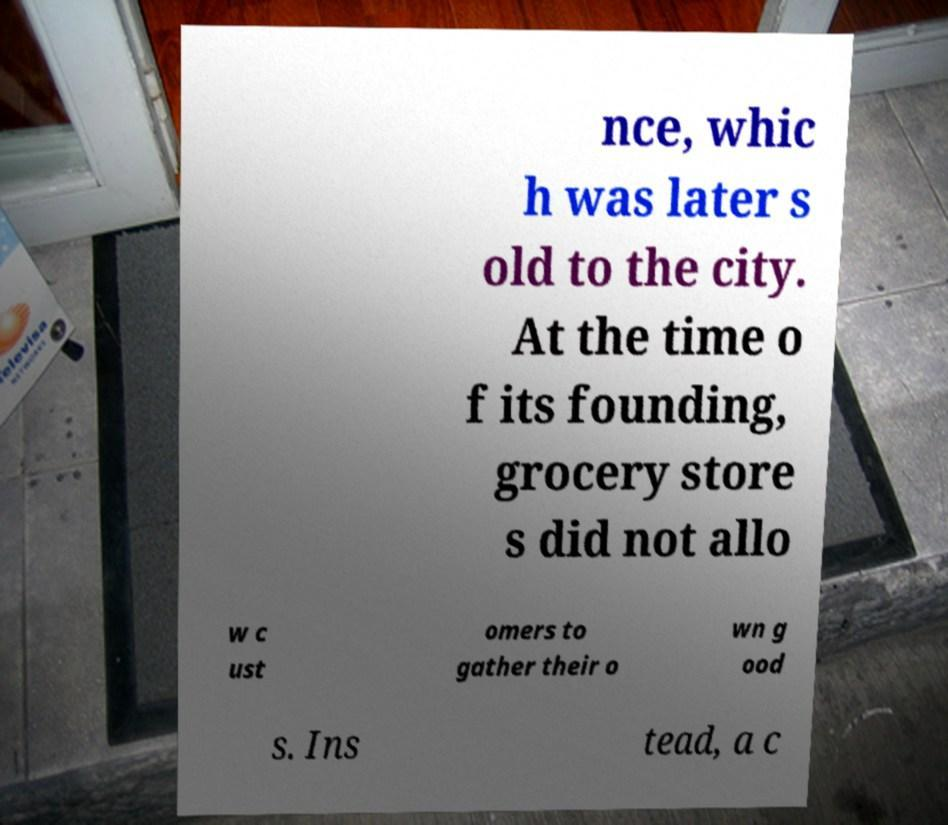Please read and relay the text visible in this image. What does it say? nce, whic h was later s old to the city. At the time o f its founding, grocery store s did not allo w c ust omers to gather their o wn g ood s. Ins tead, a c 